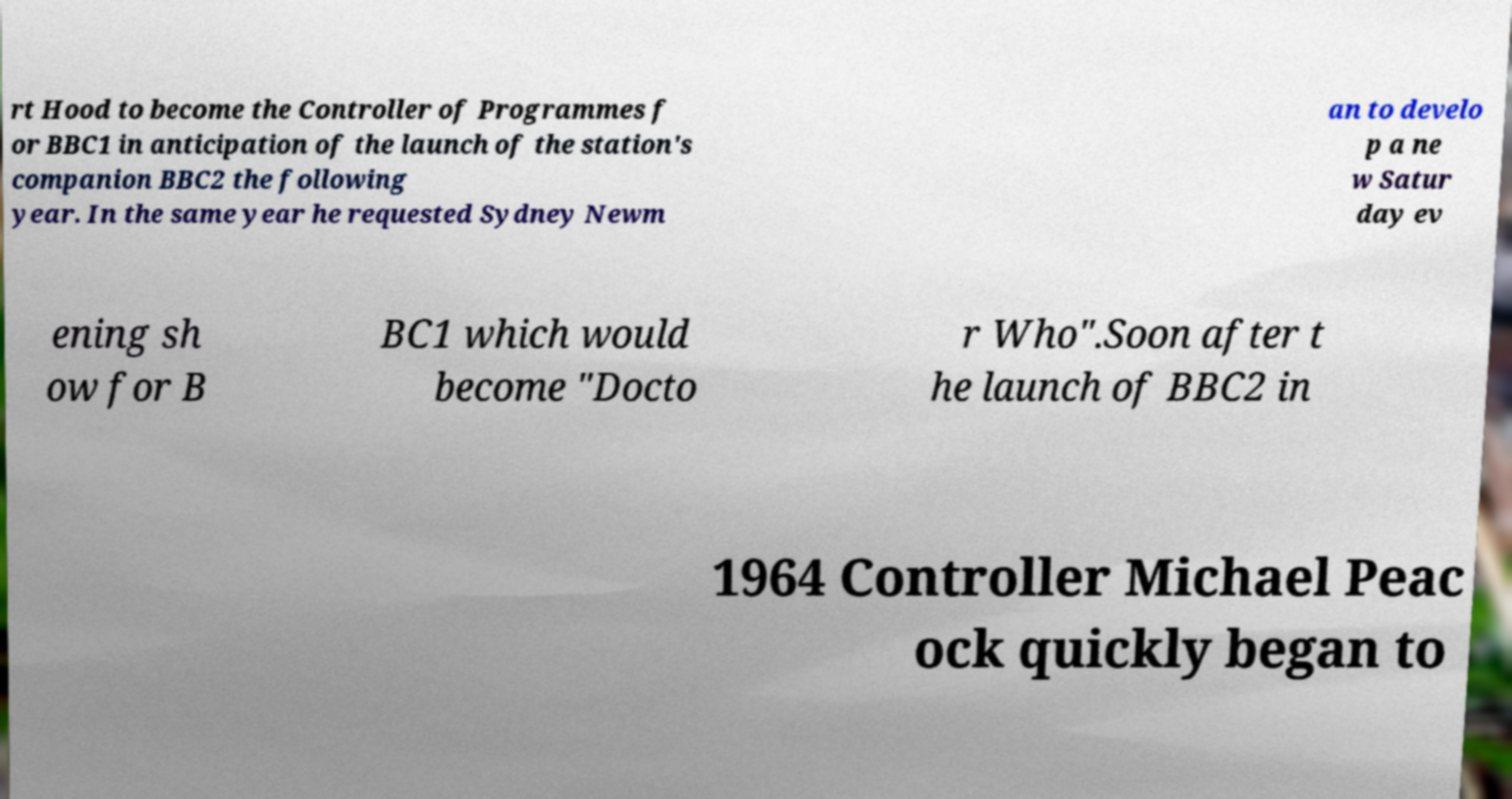Please read and relay the text visible in this image. What does it say? rt Hood to become the Controller of Programmes f or BBC1 in anticipation of the launch of the station's companion BBC2 the following year. In the same year he requested Sydney Newm an to develo p a ne w Satur day ev ening sh ow for B BC1 which would become "Docto r Who".Soon after t he launch of BBC2 in 1964 Controller Michael Peac ock quickly began to 